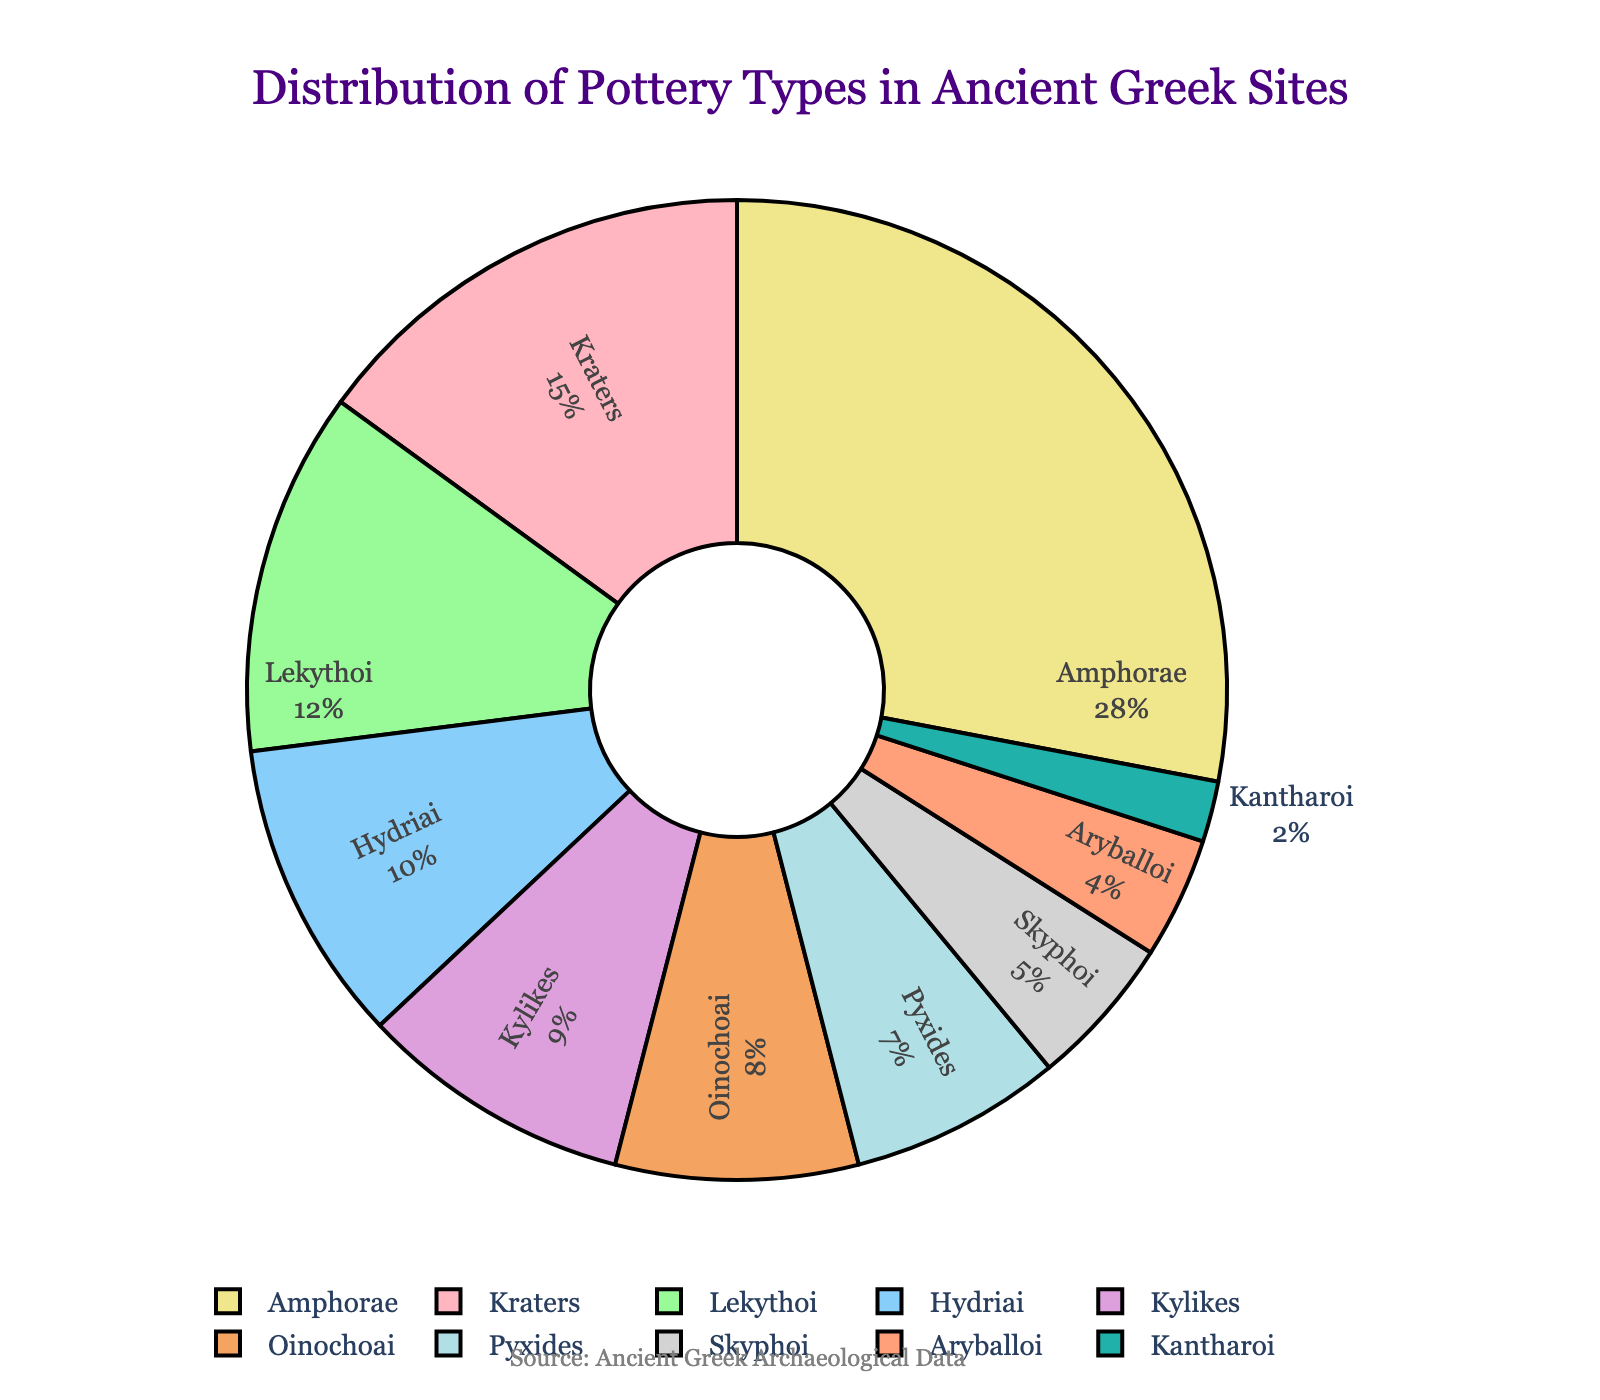Which pottery type has the highest percentage in the distribution? To find the pottery type with the highest percentage, look at the segments of the pie chart and the respective percentages. The segment with the highest value should be identified.
Answer: Amphorae How many more percent of Amphorae were found compared to Kantharoi? Identify the percentages of Amphorae and Kantharoi from the pie chart, which are 28% and 2% respectively. Subtract the percentage of Kantharoi from Amphorae: 28% - 2% = 26%.
Answer: 26% What is the combined percentage of Kryters, Lekythoi, and Kylikes? Find the percentages of Kryters, Lekythoi, and Kylikes, which are 15%, 12%, and 9% respectively. Sum these values: 15% + 12% + 9% = 36%.
Answer: 36% Which pottery type accounts for the smallest share in the distribution? Identify the smallest segment in the pie chart by observing the values. The smallest percentage given is for Kantharoi.
Answer: Kantharoi Does the combined total of Oinochoai and Hydriai exceed that of Amphorae? Identify the percentages of Oinochoai (8%) and Hydriai (10%), sum them up to get 18%. Compare this with the percentage of Amphorae, which is 28%. Since 18% is less than 28%, the combined total does not exceed that of Amphorae.
Answer: No What is the average percentage for Kylikes, Oinochoai, and Pyxides? Identify the percentages of Kylikes (9%), Oinochoai (8%), and Pyxides (7%). Calculate the sum: 9% + 8% + 7% = 24%. Divide by the number of items: 24% / 3 ≈ 8%.
Answer: 8% Which two pottery types together make up the same percentage as Amphorae alone? Identify the percentage of Amphorae, which is 28%. Find two types whose sum equals 28%. By checking different combinations, Lekythoi (12%) and Oinochoai (8%) can be combined with Hydriai (10%) to make 28%.
Answer: Lekythoi and Hydriai Is the percentage for Aryballoi greater than 5%? Identify the percentage of Aryballoi which is 4%. Compare it to 5%. Since 4% is less than 5%, the answer is no.
Answer: No 